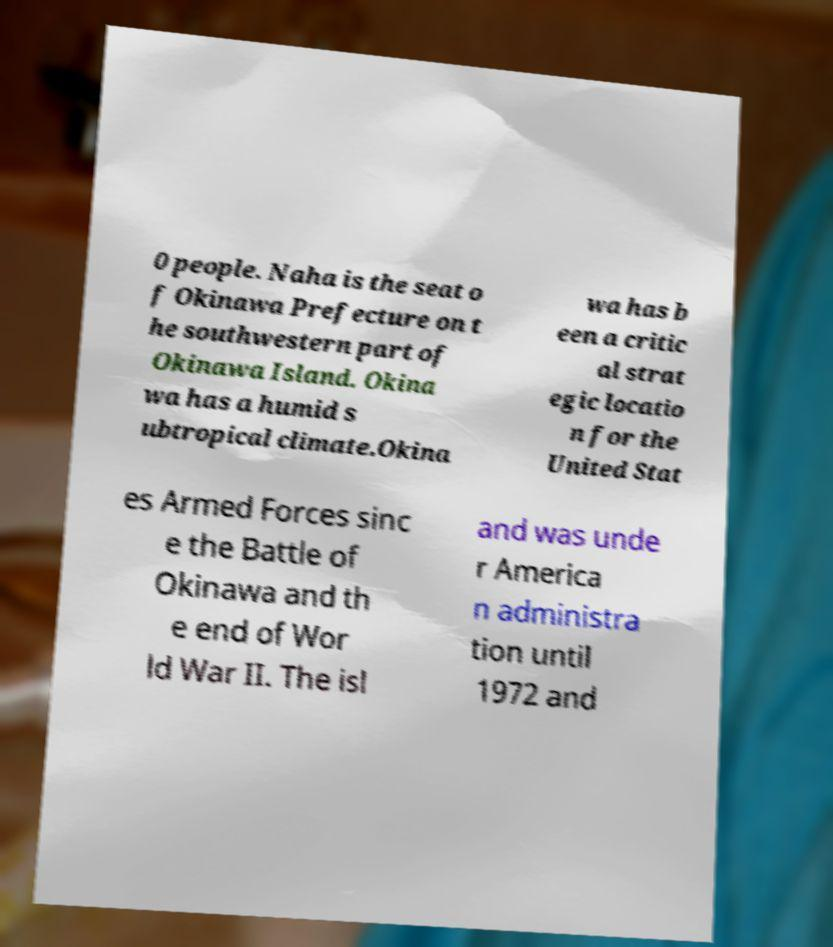Please read and relay the text visible in this image. What does it say? 0 people. Naha is the seat o f Okinawa Prefecture on t he southwestern part of Okinawa Island. Okina wa has a humid s ubtropical climate.Okina wa has b een a critic al strat egic locatio n for the United Stat es Armed Forces sinc e the Battle of Okinawa and th e end of Wor ld War II. The isl and was unde r America n administra tion until 1972 and 